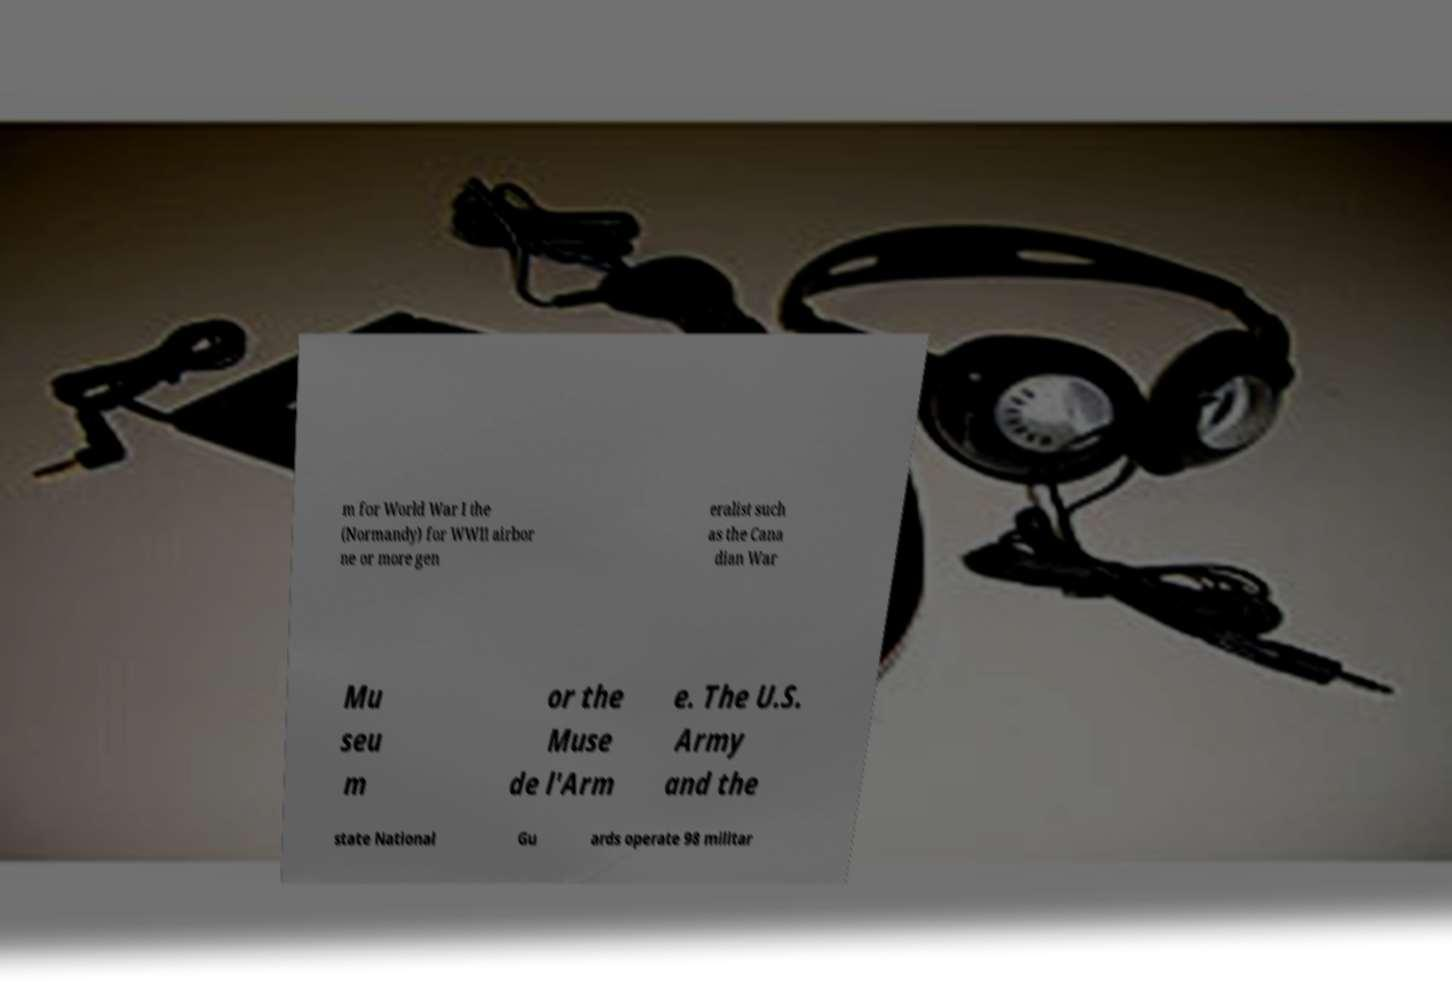Can you accurately transcribe the text from the provided image for me? m for World War I the (Normandy) for WWII airbor ne or more gen eralist such as the Cana dian War Mu seu m or the Muse de l'Arm e. The U.S. Army and the state National Gu ards operate 98 militar 